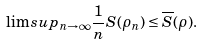Convert formula to latex. <formula><loc_0><loc_0><loc_500><loc_500>\lim s u p _ { n \rightarrow \infty } \frac { 1 } { n } S ( \rho _ { n } ) \leq \overline { S } ( \rho ) .</formula> 